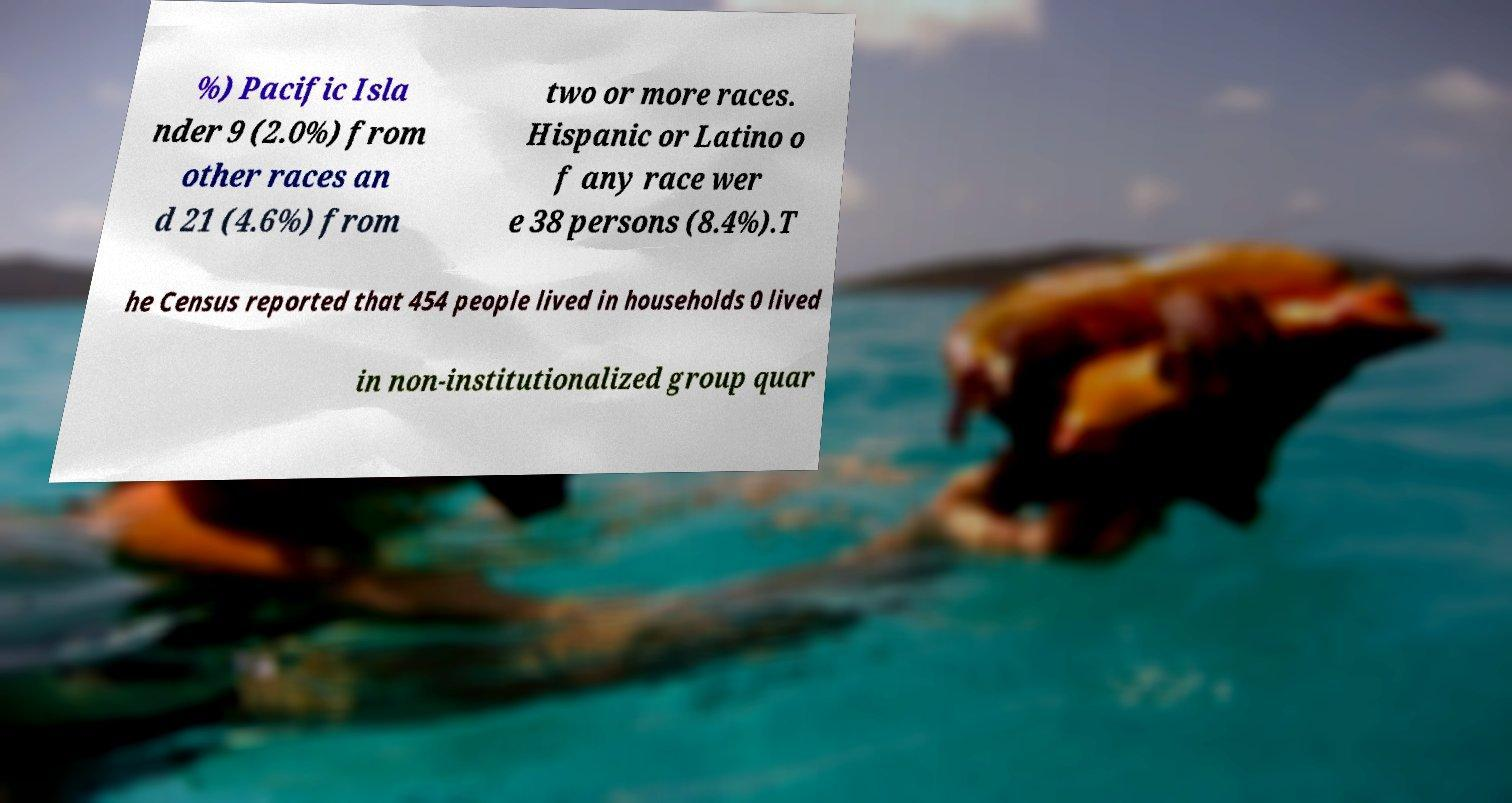For documentation purposes, I need the text within this image transcribed. Could you provide that? %) Pacific Isla nder 9 (2.0%) from other races an d 21 (4.6%) from two or more races. Hispanic or Latino o f any race wer e 38 persons (8.4%).T he Census reported that 454 people lived in households 0 lived in non-institutionalized group quar 